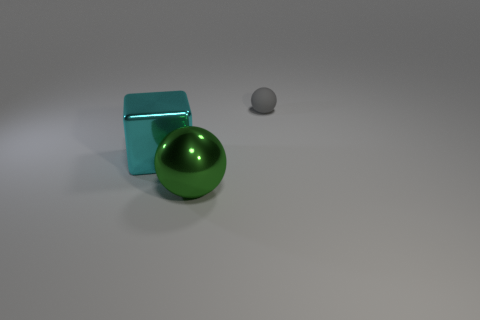What might be the purpose of these objects? These objects could be used for a variety of purposes, such as decorative pieces due to their simple yet elegant shapes, or potentially as part of a larger assembly in machinery if they are indeed made of metal. 